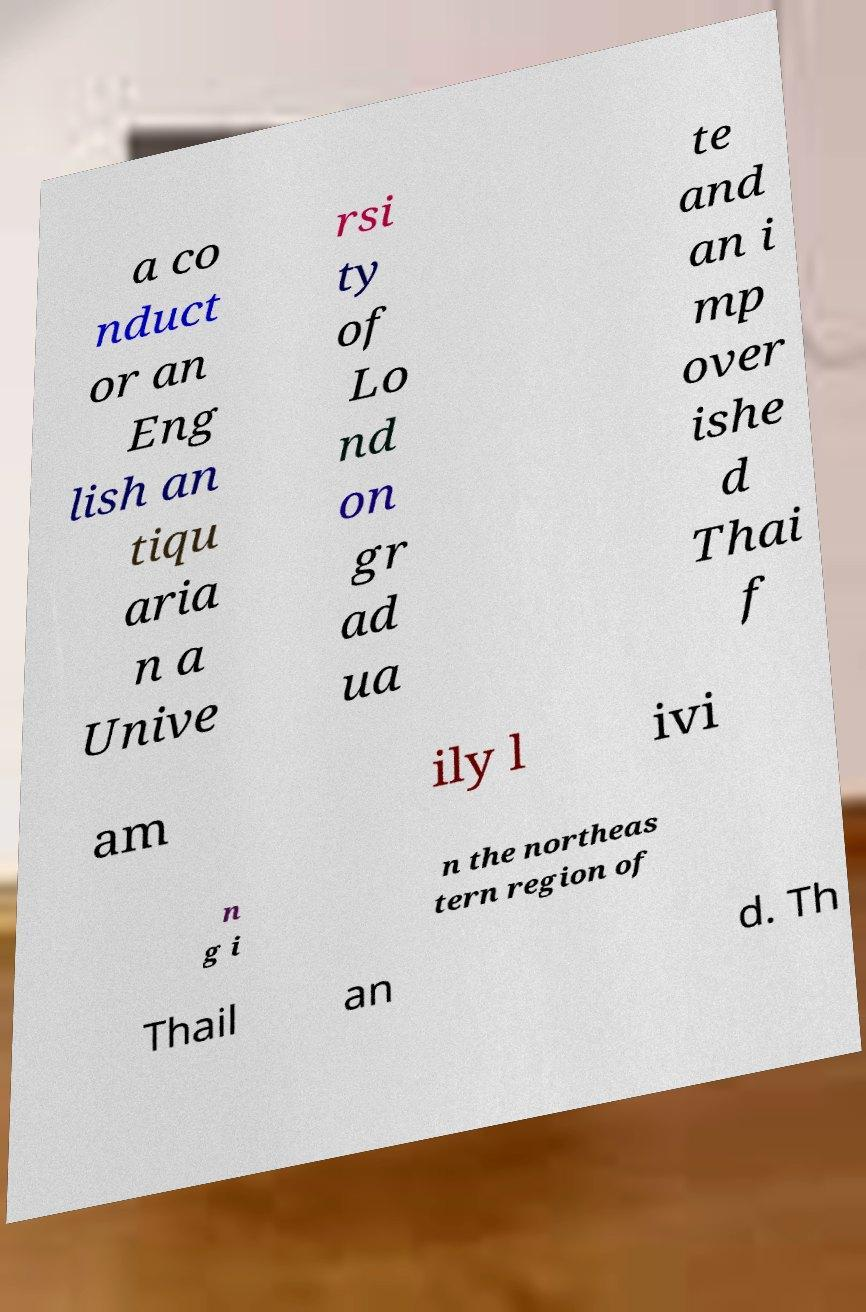Could you assist in decoding the text presented in this image and type it out clearly? a co nduct or an Eng lish an tiqu aria n a Unive rsi ty of Lo nd on gr ad ua te and an i mp over ishe d Thai f am ily l ivi n g i n the northeas tern region of Thail an d. Th 